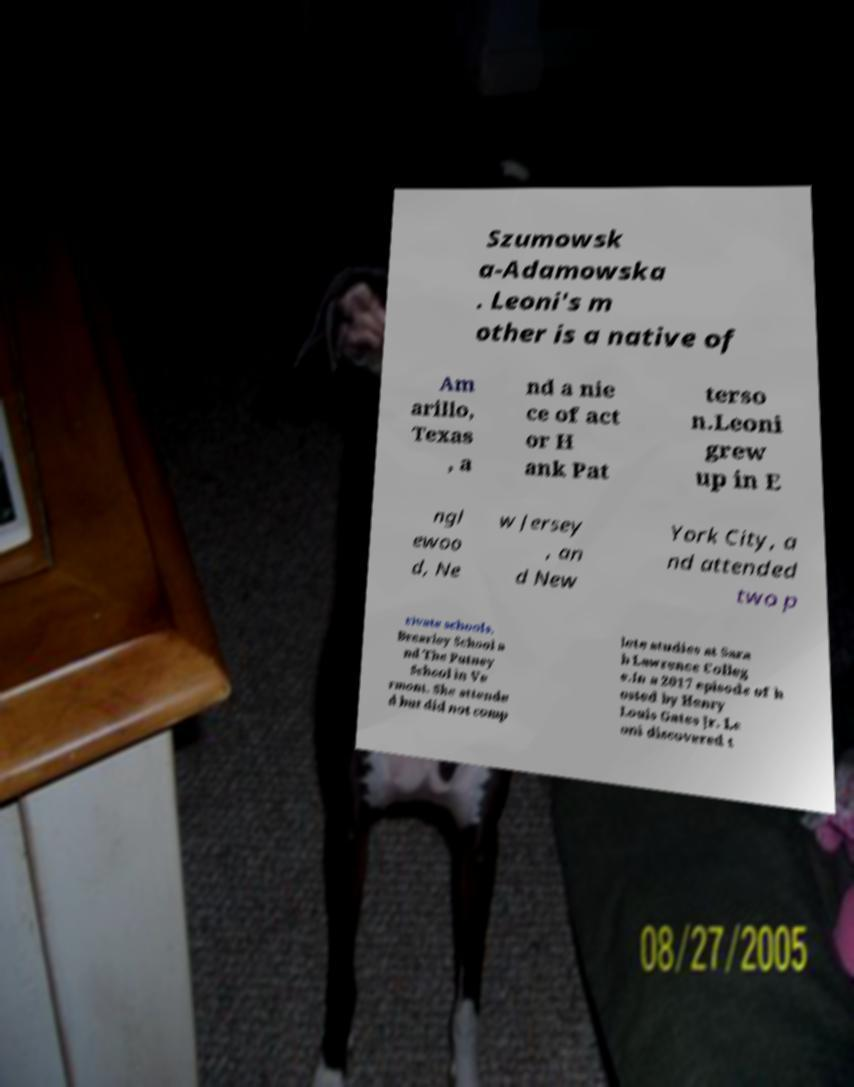Please identify and transcribe the text found in this image. Szumowsk a-Adamowska . Leoni's m other is a native of Am arillo, Texas , a nd a nie ce of act or H ank Pat terso n.Leoni grew up in E ngl ewoo d, Ne w Jersey , an d New York City, a nd attended two p rivate schools, Brearley School a nd The Putney School in Ve rmont. She attende d but did not comp lete studies at Sara h Lawrence Colleg e.In a 2017 episode of h osted by Henry Louis Gates Jr. Le oni discovered t 